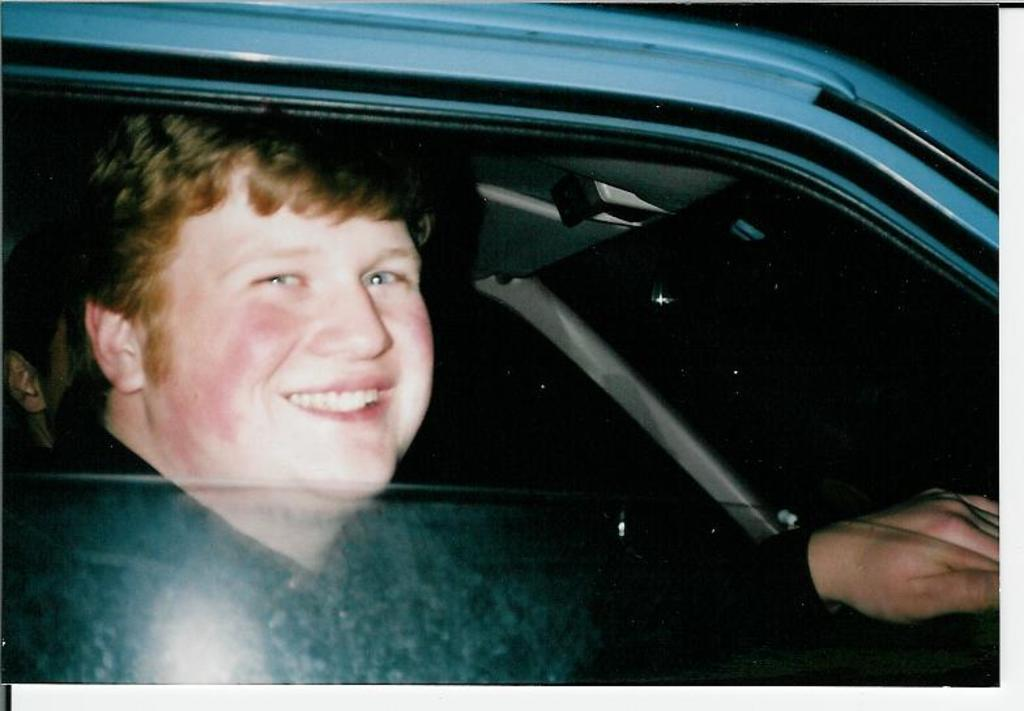Where was the image taken? The image is taken inside a car. Who is present in the image? There is a man sitting in the car. What is the man doing in the image? The man is holding a steering wheel. What is the man's facial expression in the image? The man has a smile on his face. What type of chin does the man have in the image? There is no information about the man's chin in the image, so it cannot be determined. 